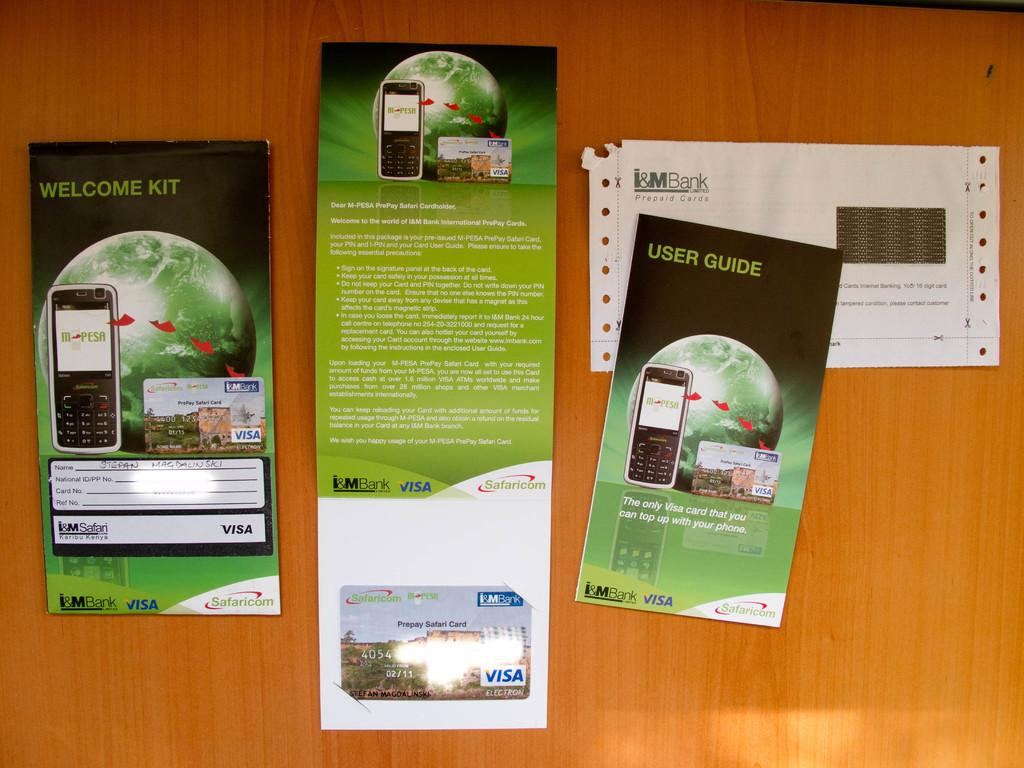<image>
Describe the image concisely. Information leaflets including the welcome kit and user guide information. 